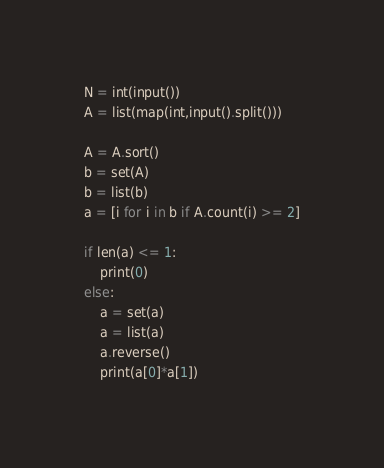<code> <loc_0><loc_0><loc_500><loc_500><_Python_>N = int(input())
A = list(map(int,input().split()))

A = A.sort()
b = set(A)
b = list(b)
a = [i for i in b if A.count(i) >= 2]

if len(a) <= 1:
    print(0)
else:
    a = set(a)
    a = list(a)
    a.reverse()
    print(a[0]*a[1])
</code> 